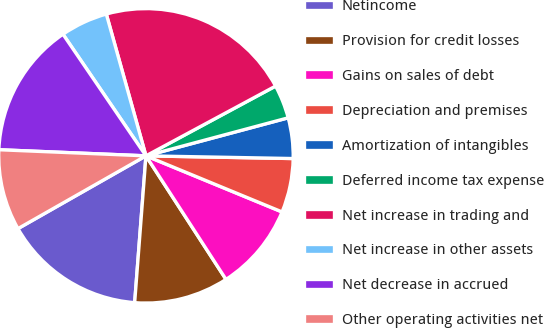Convert chart. <chart><loc_0><loc_0><loc_500><loc_500><pie_chart><fcel>Netincome<fcel>Provision for credit losses<fcel>Gains on sales of debt<fcel>Depreciation and premises<fcel>Amortization of intangibles<fcel>Deferred income tax expense<fcel>Net increase in trading and<fcel>Net increase in other assets<fcel>Net decrease in accrued<fcel>Other operating activities net<nl><fcel>15.55%<fcel>10.37%<fcel>9.63%<fcel>5.93%<fcel>4.45%<fcel>3.7%<fcel>21.48%<fcel>5.19%<fcel>14.81%<fcel>8.89%<nl></chart> 